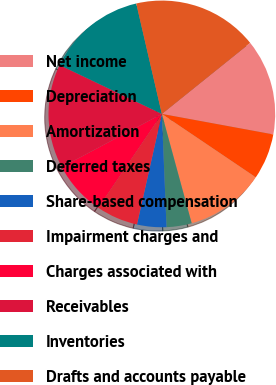Convert chart to OTSL. <chart><loc_0><loc_0><loc_500><loc_500><pie_chart><fcel>Net income<fcel>Depreciation<fcel>Amortization<fcel>Deferred taxes<fcel>Share-based compensation<fcel>Impairment charges and<fcel>Charges associated with<fcel>Receivables<fcel>Inventories<fcel>Drafts and accounts payable<nl><fcel>13.68%<fcel>6.55%<fcel>11.31%<fcel>3.58%<fcel>4.18%<fcel>5.96%<fcel>7.74%<fcel>14.87%<fcel>14.28%<fcel>17.84%<nl></chart> 